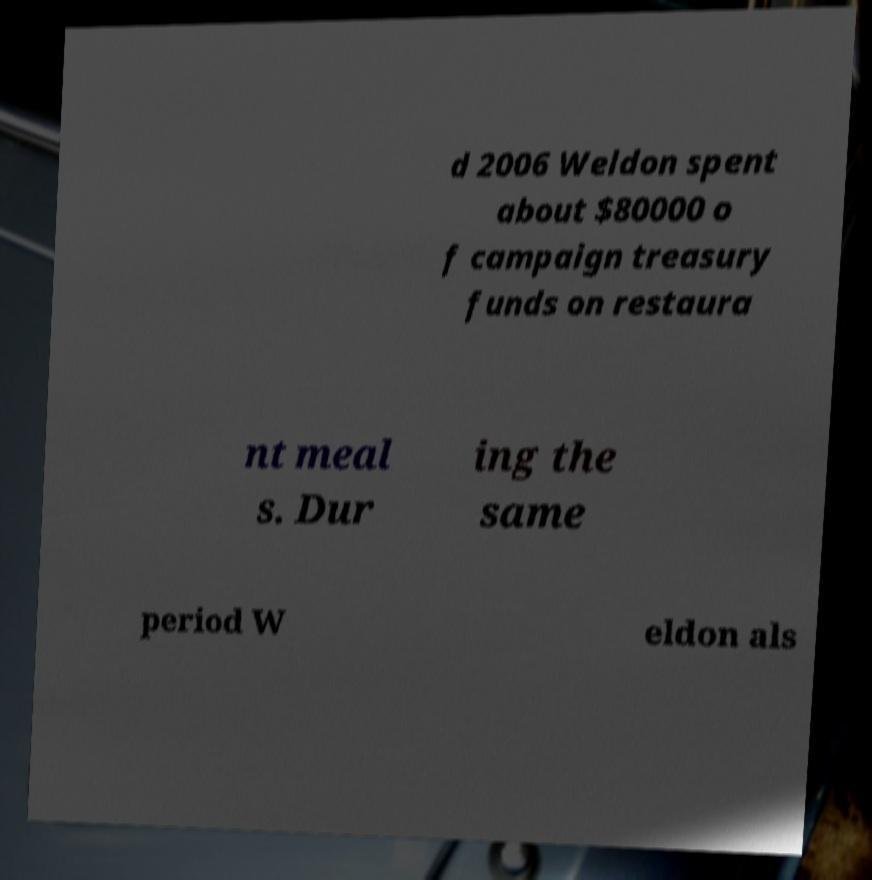Can you read and provide the text displayed in the image?This photo seems to have some interesting text. Can you extract and type it out for me? d 2006 Weldon spent about $80000 o f campaign treasury funds on restaura nt meal s. Dur ing the same period W eldon als 